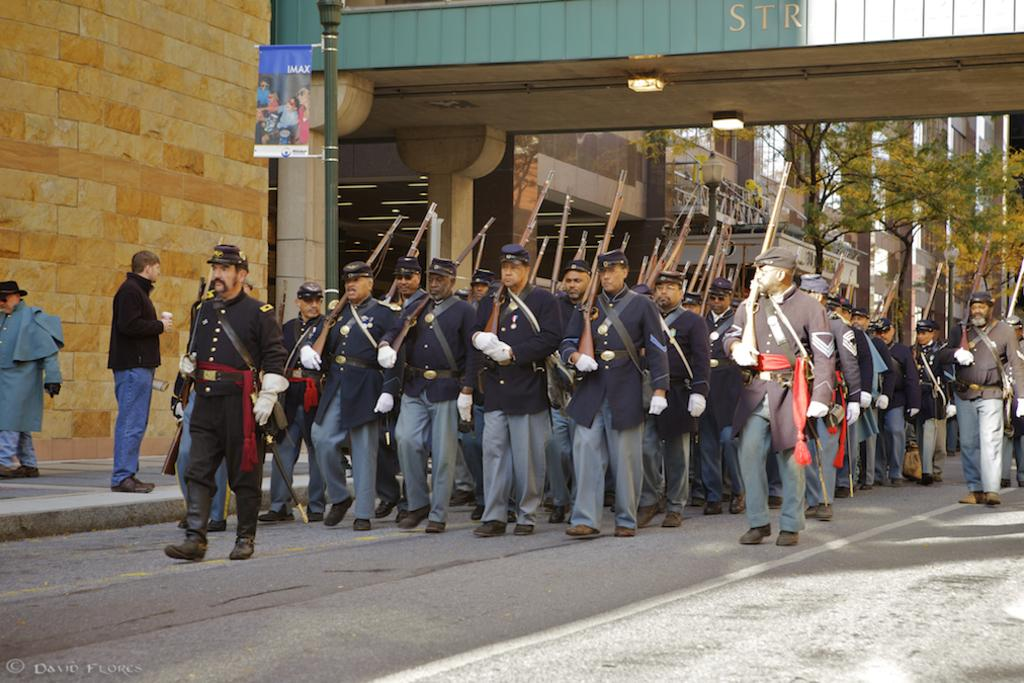What is happening on the road in the image? There is a group of people on the road in the image. What are some of the people in the group holding? Some people in the group are holding guns. What can be seen in the background of the image? There is a building, poles, a poster, trees, and lights in the background of the image. What type of silver chair is visible in the image? There is no silver chair present in the image. What is the topic of the argument taking place in the image? There is no argument present in the image. 